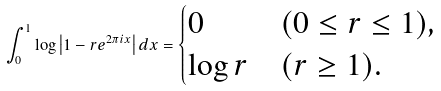Convert formula to latex. <formula><loc_0><loc_0><loc_500><loc_500>\int _ { 0 } ^ { 1 } \log \left | 1 - r e ^ { 2 \pi i x } \right | d x = \begin{cases} 0 & ( 0 \leq r \leq 1 ) , \\ \log r & ( r \geq 1 ) . \end{cases}</formula> 